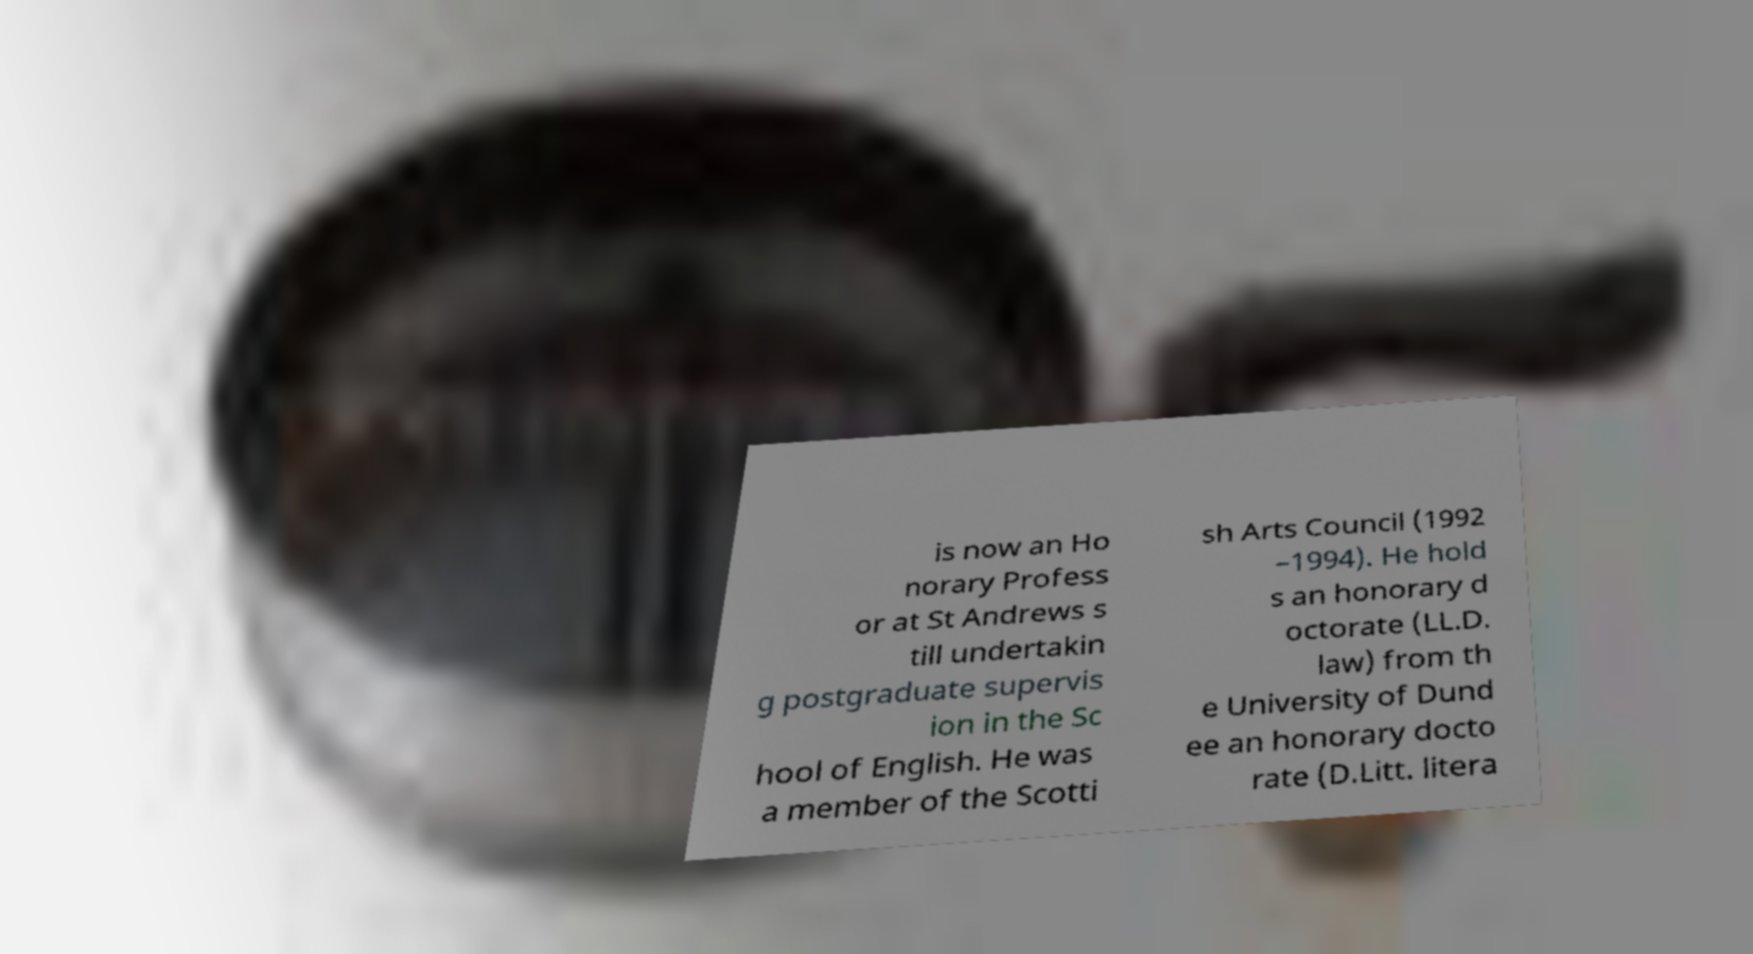Can you accurately transcribe the text from the provided image for me? is now an Ho norary Profess or at St Andrews s till undertakin g postgraduate supervis ion in the Sc hool of English. He was a member of the Scotti sh Arts Council (1992 –1994). He hold s an honorary d octorate (LL.D. law) from th e University of Dund ee an honorary docto rate (D.Litt. litera 